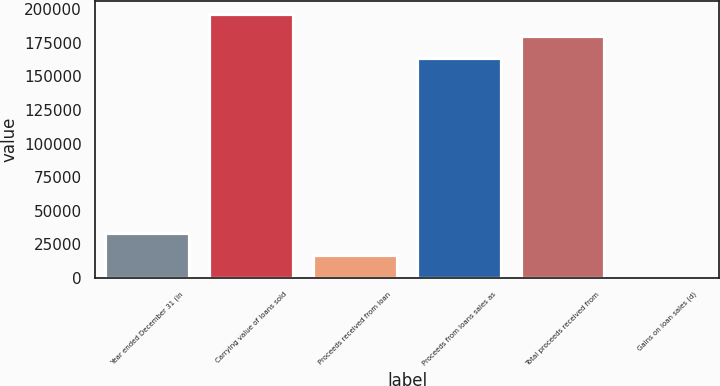Convert chart. <chart><loc_0><loc_0><loc_500><loc_500><bar_chart><fcel>Year ended December 31 (in<fcel>Carrying value of loans sold<fcel>Proceeds received from loan<fcel>Proceeds from loans sales as<fcel>Total proceeds received from<fcel>Gains on loan sales (d)<nl><fcel>33447.2<fcel>196518<fcel>16874.6<fcel>163373<fcel>179946<fcel>302<nl></chart> 